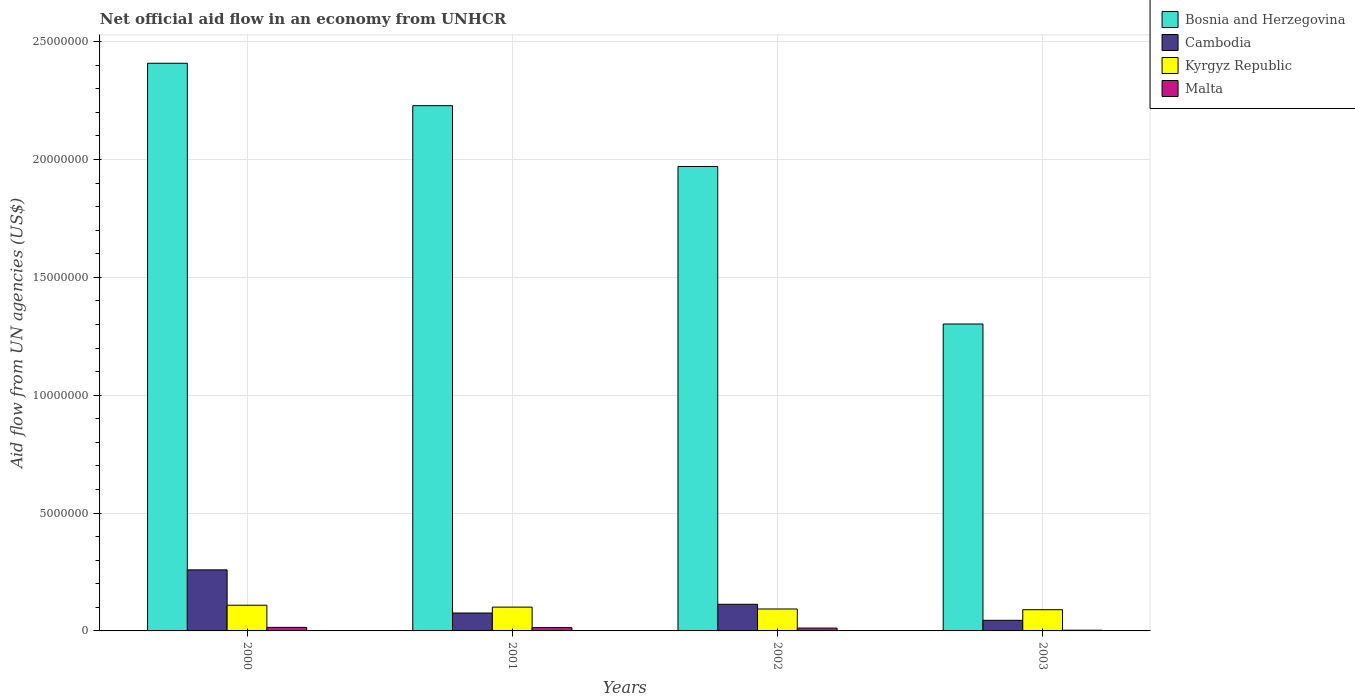How many groups of bars are there?
Keep it short and to the point. 4. Are the number of bars on each tick of the X-axis equal?
Keep it short and to the point. Yes. How many bars are there on the 1st tick from the left?
Ensure brevity in your answer.  4. What is the label of the 1st group of bars from the left?
Provide a succinct answer. 2000. In how many cases, is the number of bars for a given year not equal to the number of legend labels?
Your response must be concise. 0. Across all years, what is the maximum net official aid flow in Cambodia?
Keep it short and to the point. 2.59e+06. Across all years, what is the minimum net official aid flow in Malta?
Offer a very short reply. 3.00e+04. In which year was the net official aid flow in Cambodia minimum?
Your answer should be very brief. 2003. What is the total net official aid flow in Cambodia in the graph?
Your answer should be very brief. 4.93e+06. What is the difference between the net official aid flow in Malta in 2001 and that in 2003?
Give a very brief answer. 1.10e+05. What is the difference between the net official aid flow in Cambodia in 2000 and the net official aid flow in Malta in 2001?
Provide a short and direct response. 2.45e+06. What is the average net official aid flow in Cambodia per year?
Provide a short and direct response. 1.23e+06. In the year 2001, what is the difference between the net official aid flow in Bosnia and Herzegovina and net official aid flow in Malta?
Your answer should be compact. 2.21e+07. What is the ratio of the net official aid flow in Cambodia in 2000 to that in 2002?
Ensure brevity in your answer.  2.29. Is the net official aid flow in Kyrgyz Republic in 2000 less than that in 2003?
Make the answer very short. No. Is the difference between the net official aid flow in Bosnia and Herzegovina in 2000 and 2002 greater than the difference between the net official aid flow in Malta in 2000 and 2002?
Provide a short and direct response. Yes. What is the difference between the highest and the lowest net official aid flow in Bosnia and Herzegovina?
Offer a very short reply. 1.11e+07. What does the 4th bar from the left in 2000 represents?
Offer a terse response. Malta. What does the 1st bar from the right in 2003 represents?
Give a very brief answer. Malta. Are all the bars in the graph horizontal?
Provide a succinct answer. No. What is the difference between two consecutive major ticks on the Y-axis?
Your answer should be very brief. 5.00e+06. Does the graph contain any zero values?
Offer a terse response. No. What is the title of the graph?
Your answer should be compact. Net official aid flow in an economy from UNHCR. Does "Middle income" appear as one of the legend labels in the graph?
Your response must be concise. No. What is the label or title of the X-axis?
Offer a very short reply. Years. What is the label or title of the Y-axis?
Your answer should be very brief. Aid flow from UN agencies (US$). What is the Aid flow from UN agencies (US$) in Bosnia and Herzegovina in 2000?
Ensure brevity in your answer.  2.41e+07. What is the Aid flow from UN agencies (US$) of Cambodia in 2000?
Provide a short and direct response. 2.59e+06. What is the Aid flow from UN agencies (US$) of Kyrgyz Republic in 2000?
Offer a very short reply. 1.09e+06. What is the Aid flow from UN agencies (US$) of Malta in 2000?
Your answer should be compact. 1.50e+05. What is the Aid flow from UN agencies (US$) of Bosnia and Herzegovina in 2001?
Ensure brevity in your answer.  2.23e+07. What is the Aid flow from UN agencies (US$) in Cambodia in 2001?
Your answer should be very brief. 7.60e+05. What is the Aid flow from UN agencies (US$) in Kyrgyz Republic in 2001?
Keep it short and to the point. 1.01e+06. What is the Aid flow from UN agencies (US$) of Bosnia and Herzegovina in 2002?
Give a very brief answer. 1.97e+07. What is the Aid flow from UN agencies (US$) of Cambodia in 2002?
Offer a very short reply. 1.13e+06. What is the Aid flow from UN agencies (US$) in Kyrgyz Republic in 2002?
Provide a succinct answer. 9.30e+05. What is the Aid flow from UN agencies (US$) in Malta in 2002?
Your response must be concise. 1.20e+05. What is the Aid flow from UN agencies (US$) in Bosnia and Herzegovina in 2003?
Offer a very short reply. 1.30e+07. Across all years, what is the maximum Aid flow from UN agencies (US$) of Bosnia and Herzegovina?
Offer a very short reply. 2.41e+07. Across all years, what is the maximum Aid flow from UN agencies (US$) in Cambodia?
Offer a terse response. 2.59e+06. Across all years, what is the maximum Aid flow from UN agencies (US$) in Kyrgyz Republic?
Provide a succinct answer. 1.09e+06. Across all years, what is the minimum Aid flow from UN agencies (US$) in Bosnia and Herzegovina?
Your answer should be compact. 1.30e+07. Across all years, what is the minimum Aid flow from UN agencies (US$) in Malta?
Keep it short and to the point. 3.00e+04. What is the total Aid flow from UN agencies (US$) in Bosnia and Herzegovina in the graph?
Provide a short and direct response. 7.91e+07. What is the total Aid flow from UN agencies (US$) in Cambodia in the graph?
Give a very brief answer. 4.93e+06. What is the total Aid flow from UN agencies (US$) in Kyrgyz Republic in the graph?
Give a very brief answer. 3.93e+06. What is the difference between the Aid flow from UN agencies (US$) in Bosnia and Herzegovina in 2000 and that in 2001?
Offer a very short reply. 1.80e+06. What is the difference between the Aid flow from UN agencies (US$) in Cambodia in 2000 and that in 2001?
Offer a very short reply. 1.83e+06. What is the difference between the Aid flow from UN agencies (US$) of Bosnia and Herzegovina in 2000 and that in 2002?
Give a very brief answer. 4.38e+06. What is the difference between the Aid flow from UN agencies (US$) in Cambodia in 2000 and that in 2002?
Your response must be concise. 1.46e+06. What is the difference between the Aid flow from UN agencies (US$) in Malta in 2000 and that in 2002?
Keep it short and to the point. 3.00e+04. What is the difference between the Aid flow from UN agencies (US$) in Bosnia and Herzegovina in 2000 and that in 2003?
Make the answer very short. 1.11e+07. What is the difference between the Aid flow from UN agencies (US$) in Cambodia in 2000 and that in 2003?
Keep it short and to the point. 2.14e+06. What is the difference between the Aid flow from UN agencies (US$) in Malta in 2000 and that in 2003?
Your answer should be very brief. 1.20e+05. What is the difference between the Aid flow from UN agencies (US$) of Bosnia and Herzegovina in 2001 and that in 2002?
Keep it short and to the point. 2.58e+06. What is the difference between the Aid flow from UN agencies (US$) of Cambodia in 2001 and that in 2002?
Your answer should be very brief. -3.70e+05. What is the difference between the Aid flow from UN agencies (US$) of Kyrgyz Republic in 2001 and that in 2002?
Your response must be concise. 8.00e+04. What is the difference between the Aid flow from UN agencies (US$) of Malta in 2001 and that in 2002?
Keep it short and to the point. 2.00e+04. What is the difference between the Aid flow from UN agencies (US$) in Bosnia and Herzegovina in 2001 and that in 2003?
Offer a very short reply. 9.26e+06. What is the difference between the Aid flow from UN agencies (US$) in Kyrgyz Republic in 2001 and that in 2003?
Offer a very short reply. 1.10e+05. What is the difference between the Aid flow from UN agencies (US$) in Malta in 2001 and that in 2003?
Your answer should be very brief. 1.10e+05. What is the difference between the Aid flow from UN agencies (US$) in Bosnia and Herzegovina in 2002 and that in 2003?
Your answer should be very brief. 6.68e+06. What is the difference between the Aid flow from UN agencies (US$) in Cambodia in 2002 and that in 2003?
Your response must be concise. 6.80e+05. What is the difference between the Aid flow from UN agencies (US$) in Bosnia and Herzegovina in 2000 and the Aid flow from UN agencies (US$) in Cambodia in 2001?
Ensure brevity in your answer.  2.33e+07. What is the difference between the Aid flow from UN agencies (US$) of Bosnia and Herzegovina in 2000 and the Aid flow from UN agencies (US$) of Kyrgyz Republic in 2001?
Ensure brevity in your answer.  2.31e+07. What is the difference between the Aid flow from UN agencies (US$) of Bosnia and Herzegovina in 2000 and the Aid flow from UN agencies (US$) of Malta in 2001?
Your answer should be very brief. 2.39e+07. What is the difference between the Aid flow from UN agencies (US$) in Cambodia in 2000 and the Aid flow from UN agencies (US$) in Kyrgyz Republic in 2001?
Ensure brevity in your answer.  1.58e+06. What is the difference between the Aid flow from UN agencies (US$) in Cambodia in 2000 and the Aid flow from UN agencies (US$) in Malta in 2001?
Ensure brevity in your answer.  2.45e+06. What is the difference between the Aid flow from UN agencies (US$) of Kyrgyz Republic in 2000 and the Aid flow from UN agencies (US$) of Malta in 2001?
Provide a succinct answer. 9.50e+05. What is the difference between the Aid flow from UN agencies (US$) in Bosnia and Herzegovina in 2000 and the Aid flow from UN agencies (US$) in Cambodia in 2002?
Your response must be concise. 2.30e+07. What is the difference between the Aid flow from UN agencies (US$) of Bosnia and Herzegovina in 2000 and the Aid flow from UN agencies (US$) of Kyrgyz Republic in 2002?
Ensure brevity in your answer.  2.32e+07. What is the difference between the Aid flow from UN agencies (US$) in Bosnia and Herzegovina in 2000 and the Aid flow from UN agencies (US$) in Malta in 2002?
Provide a short and direct response. 2.40e+07. What is the difference between the Aid flow from UN agencies (US$) of Cambodia in 2000 and the Aid flow from UN agencies (US$) of Kyrgyz Republic in 2002?
Your response must be concise. 1.66e+06. What is the difference between the Aid flow from UN agencies (US$) in Cambodia in 2000 and the Aid flow from UN agencies (US$) in Malta in 2002?
Your answer should be compact. 2.47e+06. What is the difference between the Aid flow from UN agencies (US$) in Kyrgyz Republic in 2000 and the Aid flow from UN agencies (US$) in Malta in 2002?
Ensure brevity in your answer.  9.70e+05. What is the difference between the Aid flow from UN agencies (US$) of Bosnia and Herzegovina in 2000 and the Aid flow from UN agencies (US$) of Cambodia in 2003?
Ensure brevity in your answer.  2.36e+07. What is the difference between the Aid flow from UN agencies (US$) in Bosnia and Herzegovina in 2000 and the Aid flow from UN agencies (US$) in Kyrgyz Republic in 2003?
Your response must be concise. 2.32e+07. What is the difference between the Aid flow from UN agencies (US$) in Bosnia and Herzegovina in 2000 and the Aid flow from UN agencies (US$) in Malta in 2003?
Your answer should be very brief. 2.40e+07. What is the difference between the Aid flow from UN agencies (US$) in Cambodia in 2000 and the Aid flow from UN agencies (US$) in Kyrgyz Republic in 2003?
Provide a short and direct response. 1.69e+06. What is the difference between the Aid flow from UN agencies (US$) of Cambodia in 2000 and the Aid flow from UN agencies (US$) of Malta in 2003?
Make the answer very short. 2.56e+06. What is the difference between the Aid flow from UN agencies (US$) in Kyrgyz Republic in 2000 and the Aid flow from UN agencies (US$) in Malta in 2003?
Your answer should be very brief. 1.06e+06. What is the difference between the Aid flow from UN agencies (US$) of Bosnia and Herzegovina in 2001 and the Aid flow from UN agencies (US$) of Cambodia in 2002?
Provide a short and direct response. 2.12e+07. What is the difference between the Aid flow from UN agencies (US$) in Bosnia and Herzegovina in 2001 and the Aid flow from UN agencies (US$) in Kyrgyz Republic in 2002?
Provide a short and direct response. 2.14e+07. What is the difference between the Aid flow from UN agencies (US$) in Bosnia and Herzegovina in 2001 and the Aid flow from UN agencies (US$) in Malta in 2002?
Make the answer very short. 2.22e+07. What is the difference between the Aid flow from UN agencies (US$) in Cambodia in 2001 and the Aid flow from UN agencies (US$) in Kyrgyz Republic in 2002?
Keep it short and to the point. -1.70e+05. What is the difference between the Aid flow from UN agencies (US$) of Cambodia in 2001 and the Aid flow from UN agencies (US$) of Malta in 2002?
Offer a very short reply. 6.40e+05. What is the difference between the Aid flow from UN agencies (US$) of Kyrgyz Republic in 2001 and the Aid flow from UN agencies (US$) of Malta in 2002?
Your answer should be very brief. 8.90e+05. What is the difference between the Aid flow from UN agencies (US$) of Bosnia and Herzegovina in 2001 and the Aid flow from UN agencies (US$) of Cambodia in 2003?
Your answer should be compact. 2.18e+07. What is the difference between the Aid flow from UN agencies (US$) in Bosnia and Herzegovina in 2001 and the Aid flow from UN agencies (US$) in Kyrgyz Republic in 2003?
Provide a short and direct response. 2.14e+07. What is the difference between the Aid flow from UN agencies (US$) in Bosnia and Herzegovina in 2001 and the Aid flow from UN agencies (US$) in Malta in 2003?
Ensure brevity in your answer.  2.22e+07. What is the difference between the Aid flow from UN agencies (US$) of Cambodia in 2001 and the Aid flow from UN agencies (US$) of Malta in 2003?
Your answer should be compact. 7.30e+05. What is the difference between the Aid flow from UN agencies (US$) of Kyrgyz Republic in 2001 and the Aid flow from UN agencies (US$) of Malta in 2003?
Make the answer very short. 9.80e+05. What is the difference between the Aid flow from UN agencies (US$) of Bosnia and Herzegovina in 2002 and the Aid flow from UN agencies (US$) of Cambodia in 2003?
Offer a very short reply. 1.92e+07. What is the difference between the Aid flow from UN agencies (US$) of Bosnia and Herzegovina in 2002 and the Aid flow from UN agencies (US$) of Kyrgyz Republic in 2003?
Provide a succinct answer. 1.88e+07. What is the difference between the Aid flow from UN agencies (US$) of Bosnia and Herzegovina in 2002 and the Aid flow from UN agencies (US$) of Malta in 2003?
Provide a short and direct response. 1.97e+07. What is the difference between the Aid flow from UN agencies (US$) of Cambodia in 2002 and the Aid flow from UN agencies (US$) of Malta in 2003?
Provide a short and direct response. 1.10e+06. What is the average Aid flow from UN agencies (US$) in Bosnia and Herzegovina per year?
Provide a succinct answer. 1.98e+07. What is the average Aid flow from UN agencies (US$) in Cambodia per year?
Keep it short and to the point. 1.23e+06. What is the average Aid flow from UN agencies (US$) in Kyrgyz Republic per year?
Offer a terse response. 9.82e+05. In the year 2000, what is the difference between the Aid flow from UN agencies (US$) in Bosnia and Herzegovina and Aid flow from UN agencies (US$) in Cambodia?
Give a very brief answer. 2.15e+07. In the year 2000, what is the difference between the Aid flow from UN agencies (US$) in Bosnia and Herzegovina and Aid flow from UN agencies (US$) in Kyrgyz Republic?
Your answer should be compact. 2.30e+07. In the year 2000, what is the difference between the Aid flow from UN agencies (US$) in Bosnia and Herzegovina and Aid flow from UN agencies (US$) in Malta?
Give a very brief answer. 2.39e+07. In the year 2000, what is the difference between the Aid flow from UN agencies (US$) in Cambodia and Aid flow from UN agencies (US$) in Kyrgyz Republic?
Offer a very short reply. 1.50e+06. In the year 2000, what is the difference between the Aid flow from UN agencies (US$) in Cambodia and Aid flow from UN agencies (US$) in Malta?
Provide a succinct answer. 2.44e+06. In the year 2000, what is the difference between the Aid flow from UN agencies (US$) in Kyrgyz Republic and Aid flow from UN agencies (US$) in Malta?
Your answer should be very brief. 9.40e+05. In the year 2001, what is the difference between the Aid flow from UN agencies (US$) in Bosnia and Herzegovina and Aid flow from UN agencies (US$) in Cambodia?
Provide a succinct answer. 2.15e+07. In the year 2001, what is the difference between the Aid flow from UN agencies (US$) of Bosnia and Herzegovina and Aid flow from UN agencies (US$) of Kyrgyz Republic?
Your answer should be very brief. 2.13e+07. In the year 2001, what is the difference between the Aid flow from UN agencies (US$) of Bosnia and Herzegovina and Aid flow from UN agencies (US$) of Malta?
Keep it short and to the point. 2.21e+07. In the year 2001, what is the difference between the Aid flow from UN agencies (US$) of Cambodia and Aid flow from UN agencies (US$) of Malta?
Make the answer very short. 6.20e+05. In the year 2001, what is the difference between the Aid flow from UN agencies (US$) in Kyrgyz Republic and Aid flow from UN agencies (US$) in Malta?
Provide a succinct answer. 8.70e+05. In the year 2002, what is the difference between the Aid flow from UN agencies (US$) in Bosnia and Herzegovina and Aid flow from UN agencies (US$) in Cambodia?
Provide a short and direct response. 1.86e+07. In the year 2002, what is the difference between the Aid flow from UN agencies (US$) of Bosnia and Herzegovina and Aid flow from UN agencies (US$) of Kyrgyz Republic?
Make the answer very short. 1.88e+07. In the year 2002, what is the difference between the Aid flow from UN agencies (US$) of Bosnia and Herzegovina and Aid flow from UN agencies (US$) of Malta?
Provide a succinct answer. 1.96e+07. In the year 2002, what is the difference between the Aid flow from UN agencies (US$) of Cambodia and Aid flow from UN agencies (US$) of Malta?
Ensure brevity in your answer.  1.01e+06. In the year 2002, what is the difference between the Aid flow from UN agencies (US$) of Kyrgyz Republic and Aid flow from UN agencies (US$) of Malta?
Your answer should be very brief. 8.10e+05. In the year 2003, what is the difference between the Aid flow from UN agencies (US$) of Bosnia and Herzegovina and Aid flow from UN agencies (US$) of Cambodia?
Offer a terse response. 1.26e+07. In the year 2003, what is the difference between the Aid flow from UN agencies (US$) of Bosnia and Herzegovina and Aid flow from UN agencies (US$) of Kyrgyz Republic?
Provide a succinct answer. 1.21e+07. In the year 2003, what is the difference between the Aid flow from UN agencies (US$) in Bosnia and Herzegovina and Aid flow from UN agencies (US$) in Malta?
Provide a short and direct response. 1.30e+07. In the year 2003, what is the difference between the Aid flow from UN agencies (US$) of Cambodia and Aid flow from UN agencies (US$) of Kyrgyz Republic?
Your response must be concise. -4.50e+05. In the year 2003, what is the difference between the Aid flow from UN agencies (US$) in Kyrgyz Republic and Aid flow from UN agencies (US$) in Malta?
Keep it short and to the point. 8.70e+05. What is the ratio of the Aid flow from UN agencies (US$) of Bosnia and Herzegovina in 2000 to that in 2001?
Your answer should be very brief. 1.08. What is the ratio of the Aid flow from UN agencies (US$) of Cambodia in 2000 to that in 2001?
Offer a very short reply. 3.41. What is the ratio of the Aid flow from UN agencies (US$) in Kyrgyz Republic in 2000 to that in 2001?
Your response must be concise. 1.08. What is the ratio of the Aid flow from UN agencies (US$) in Malta in 2000 to that in 2001?
Give a very brief answer. 1.07. What is the ratio of the Aid flow from UN agencies (US$) of Bosnia and Herzegovina in 2000 to that in 2002?
Ensure brevity in your answer.  1.22. What is the ratio of the Aid flow from UN agencies (US$) of Cambodia in 2000 to that in 2002?
Ensure brevity in your answer.  2.29. What is the ratio of the Aid flow from UN agencies (US$) in Kyrgyz Republic in 2000 to that in 2002?
Offer a terse response. 1.17. What is the ratio of the Aid flow from UN agencies (US$) of Bosnia and Herzegovina in 2000 to that in 2003?
Offer a terse response. 1.85. What is the ratio of the Aid flow from UN agencies (US$) of Cambodia in 2000 to that in 2003?
Your response must be concise. 5.76. What is the ratio of the Aid flow from UN agencies (US$) of Kyrgyz Republic in 2000 to that in 2003?
Your response must be concise. 1.21. What is the ratio of the Aid flow from UN agencies (US$) of Bosnia and Herzegovina in 2001 to that in 2002?
Offer a terse response. 1.13. What is the ratio of the Aid flow from UN agencies (US$) in Cambodia in 2001 to that in 2002?
Provide a short and direct response. 0.67. What is the ratio of the Aid flow from UN agencies (US$) of Kyrgyz Republic in 2001 to that in 2002?
Provide a succinct answer. 1.09. What is the ratio of the Aid flow from UN agencies (US$) in Bosnia and Herzegovina in 2001 to that in 2003?
Provide a succinct answer. 1.71. What is the ratio of the Aid flow from UN agencies (US$) in Cambodia in 2001 to that in 2003?
Give a very brief answer. 1.69. What is the ratio of the Aid flow from UN agencies (US$) in Kyrgyz Republic in 2001 to that in 2003?
Offer a terse response. 1.12. What is the ratio of the Aid flow from UN agencies (US$) in Malta in 2001 to that in 2003?
Your response must be concise. 4.67. What is the ratio of the Aid flow from UN agencies (US$) of Bosnia and Herzegovina in 2002 to that in 2003?
Offer a terse response. 1.51. What is the ratio of the Aid flow from UN agencies (US$) in Cambodia in 2002 to that in 2003?
Make the answer very short. 2.51. What is the ratio of the Aid flow from UN agencies (US$) in Malta in 2002 to that in 2003?
Your response must be concise. 4. What is the difference between the highest and the second highest Aid flow from UN agencies (US$) of Bosnia and Herzegovina?
Keep it short and to the point. 1.80e+06. What is the difference between the highest and the second highest Aid flow from UN agencies (US$) of Cambodia?
Give a very brief answer. 1.46e+06. What is the difference between the highest and the second highest Aid flow from UN agencies (US$) in Kyrgyz Republic?
Provide a succinct answer. 8.00e+04. What is the difference between the highest and the second highest Aid flow from UN agencies (US$) in Malta?
Provide a short and direct response. 10000. What is the difference between the highest and the lowest Aid flow from UN agencies (US$) in Bosnia and Herzegovina?
Your answer should be compact. 1.11e+07. What is the difference between the highest and the lowest Aid flow from UN agencies (US$) of Cambodia?
Your answer should be compact. 2.14e+06. What is the difference between the highest and the lowest Aid flow from UN agencies (US$) of Kyrgyz Republic?
Keep it short and to the point. 1.90e+05. 